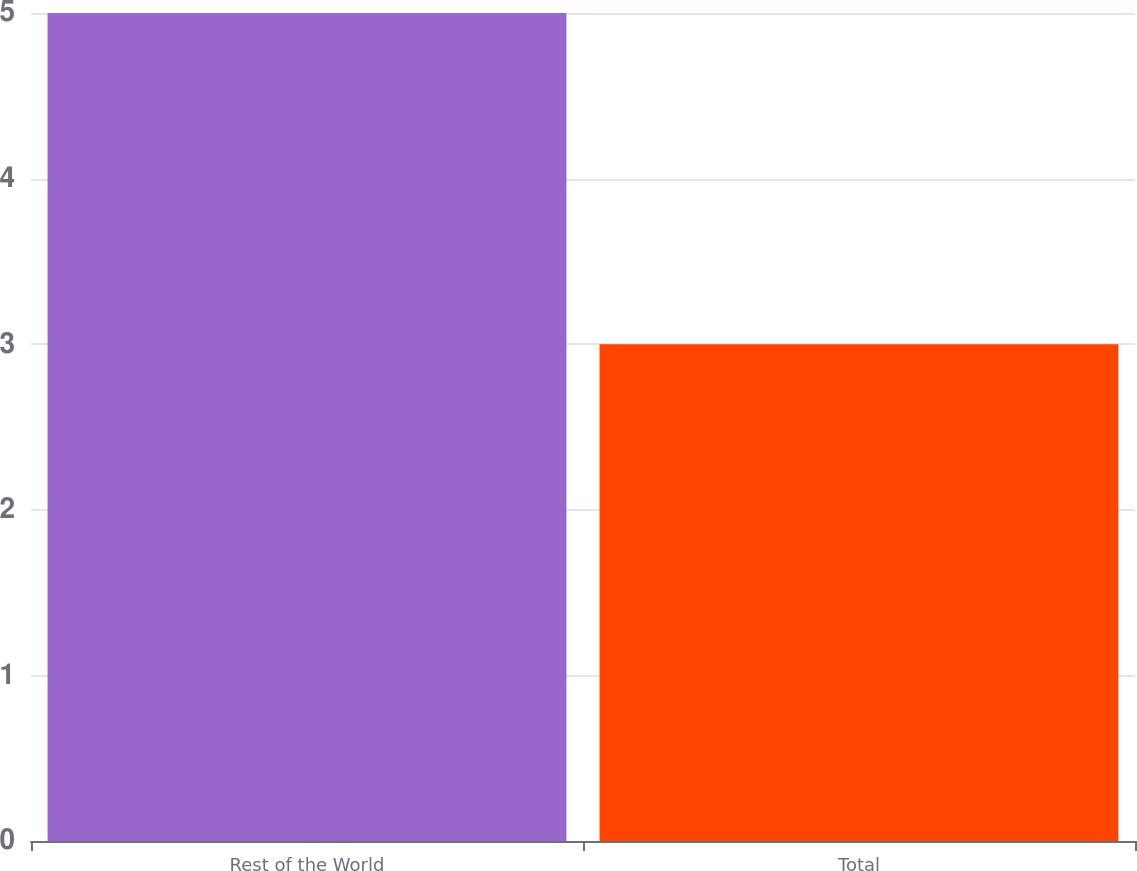Convert chart. <chart><loc_0><loc_0><loc_500><loc_500><bar_chart><fcel>Rest of the World<fcel>Total<nl><fcel>5<fcel>3<nl></chart> 